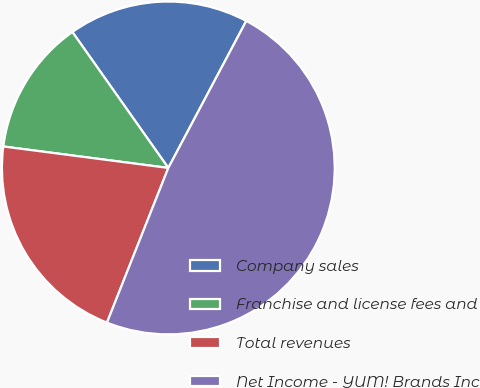Convert chart to OTSL. <chart><loc_0><loc_0><loc_500><loc_500><pie_chart><fcel>Company sales<fcel>Franchise and license fees and<fcel>Total revenues<fcel>Net Income - YUM! Brands Inc<nl><fcel>17.54%<fcel>13.16%<fcel>21.05%<fcel>48.25%<nl></chart> 